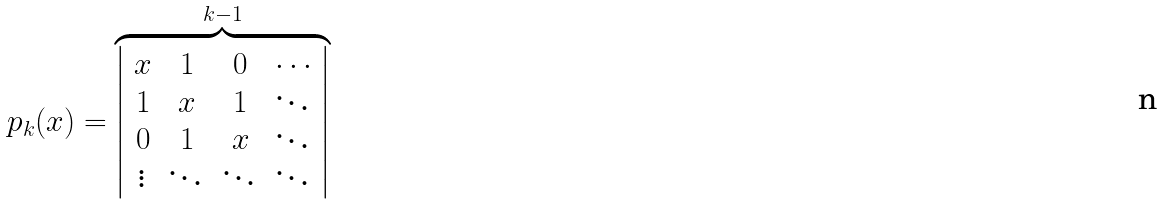Convert formula to latex. <formula><loc_0><loc_0><loc_500><loc_500>p _ { k } ( x ) = \overbrace { \left | \begin{array} { c c c c } x & 1 & 0 & \cdots \\ 1 & x & 1 & \ddots \\ 0 & 1 & x & \ddots \\ \vdots & \ddots & \ddots & \ddots \end{array} \right | } ^ { k - 1 }</formula> 